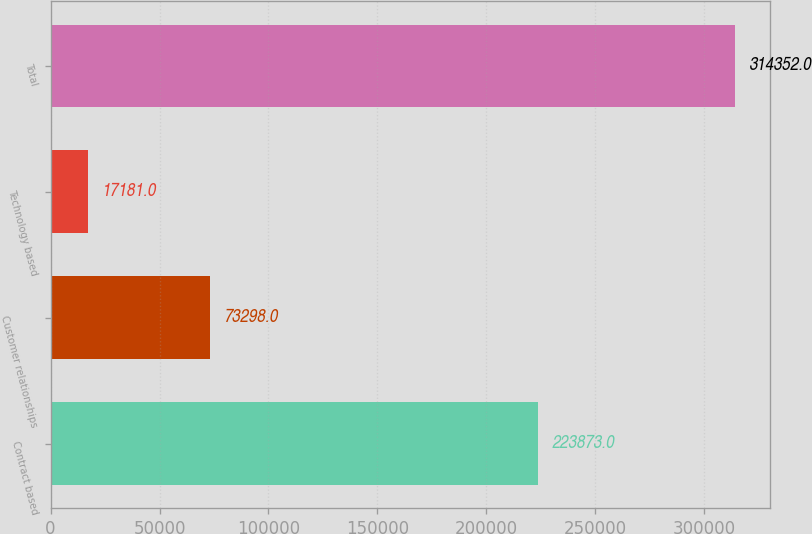Convert chart to OTSL. <chart><loc_0><loc_0><loc_500><loc_500><bar_chart><fcel>Contract based<fcel>Customer relationships<fcel>Technology based<fcel>Total<nl><fcel>223873<fcel>73298<fcel>17181<fcel>314352<nl></chart> 